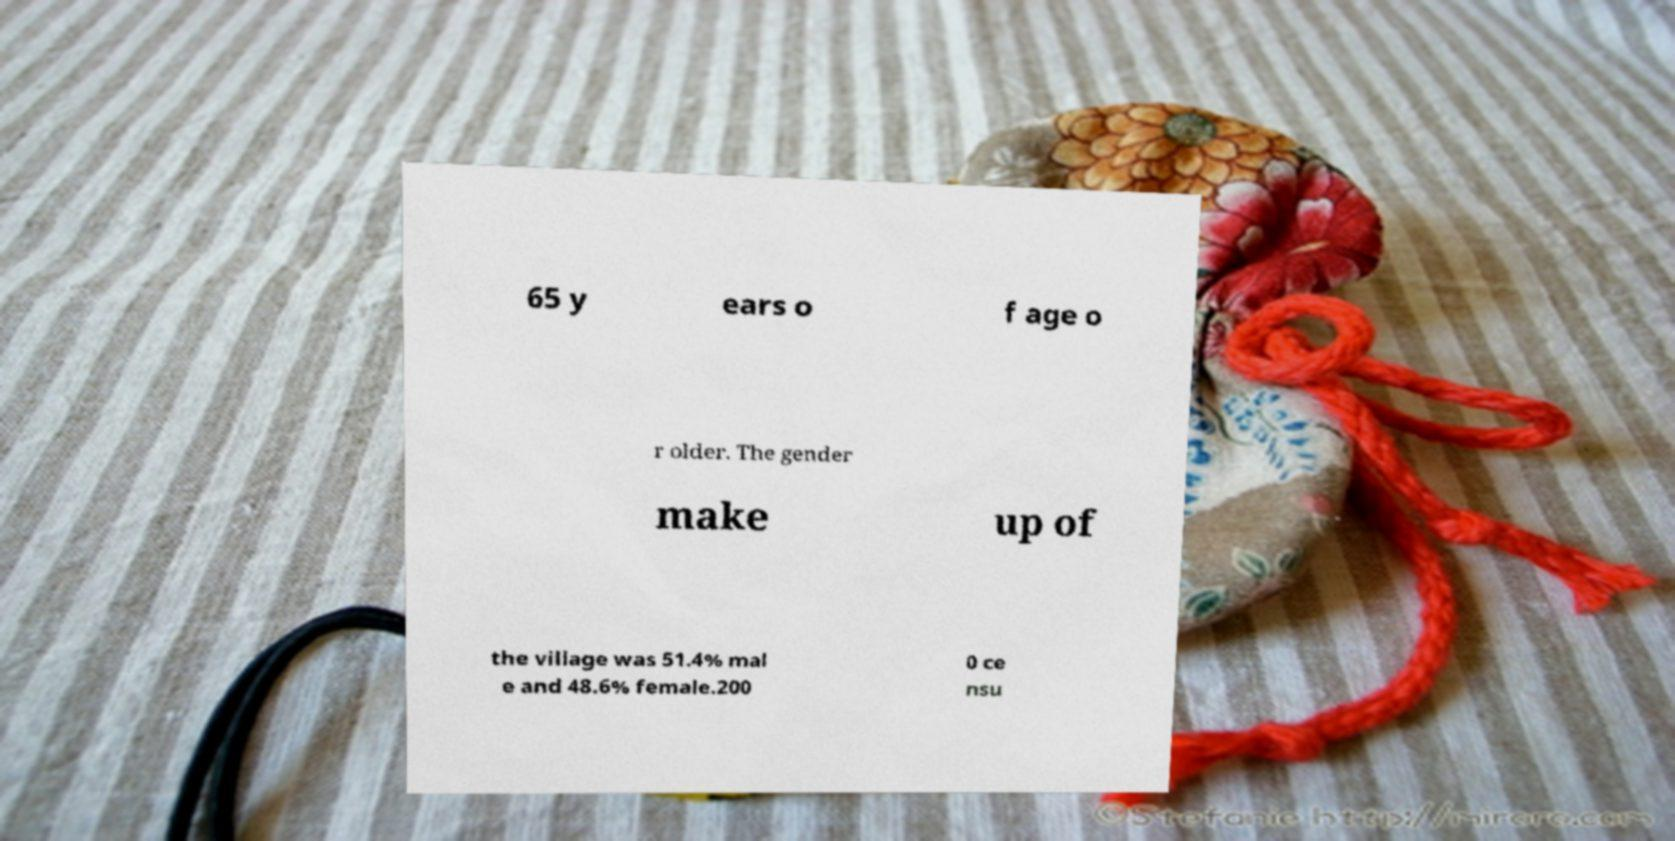Could you extract and type out the text from this image? 65 y ears o f age o r older. The gender make up of the village was 51.4% mal e and 48.6% female.200 0 ce nsu 